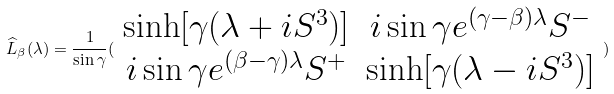Convert formula to latex. <formula><loc_0><loc_0><loc_500><loc_500>\widehat { L } _ { \beta } ( \lambda ) = \frac { 1 } { \sin \gamma } ( \begin{array} { c c } \sinh [ \gamma ( \lambda + i S ^ { 3 } ) ] & i \sin \gamma e ^ { ( \gamma - \beta ) \lambda } S ^ { - } \\ i \sin \gamma e ^ { ( \beta - \gamma ) \lambda } S ^ { + } & \sinh [ \gamma ( \lambda - i S ^ { 3 } ) ] \end{array} )</formula> 